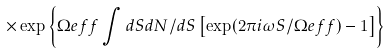Convert formula to latex. <formula><loc_0><loc_0><loc_500><loc_500>\times \exp \left \{ \Omega e f f \int d S d N / d S \left [ \exp ( 2 \pi i \omega S / \Omega e f f ) - 1 \right ] \right \}</formula> 